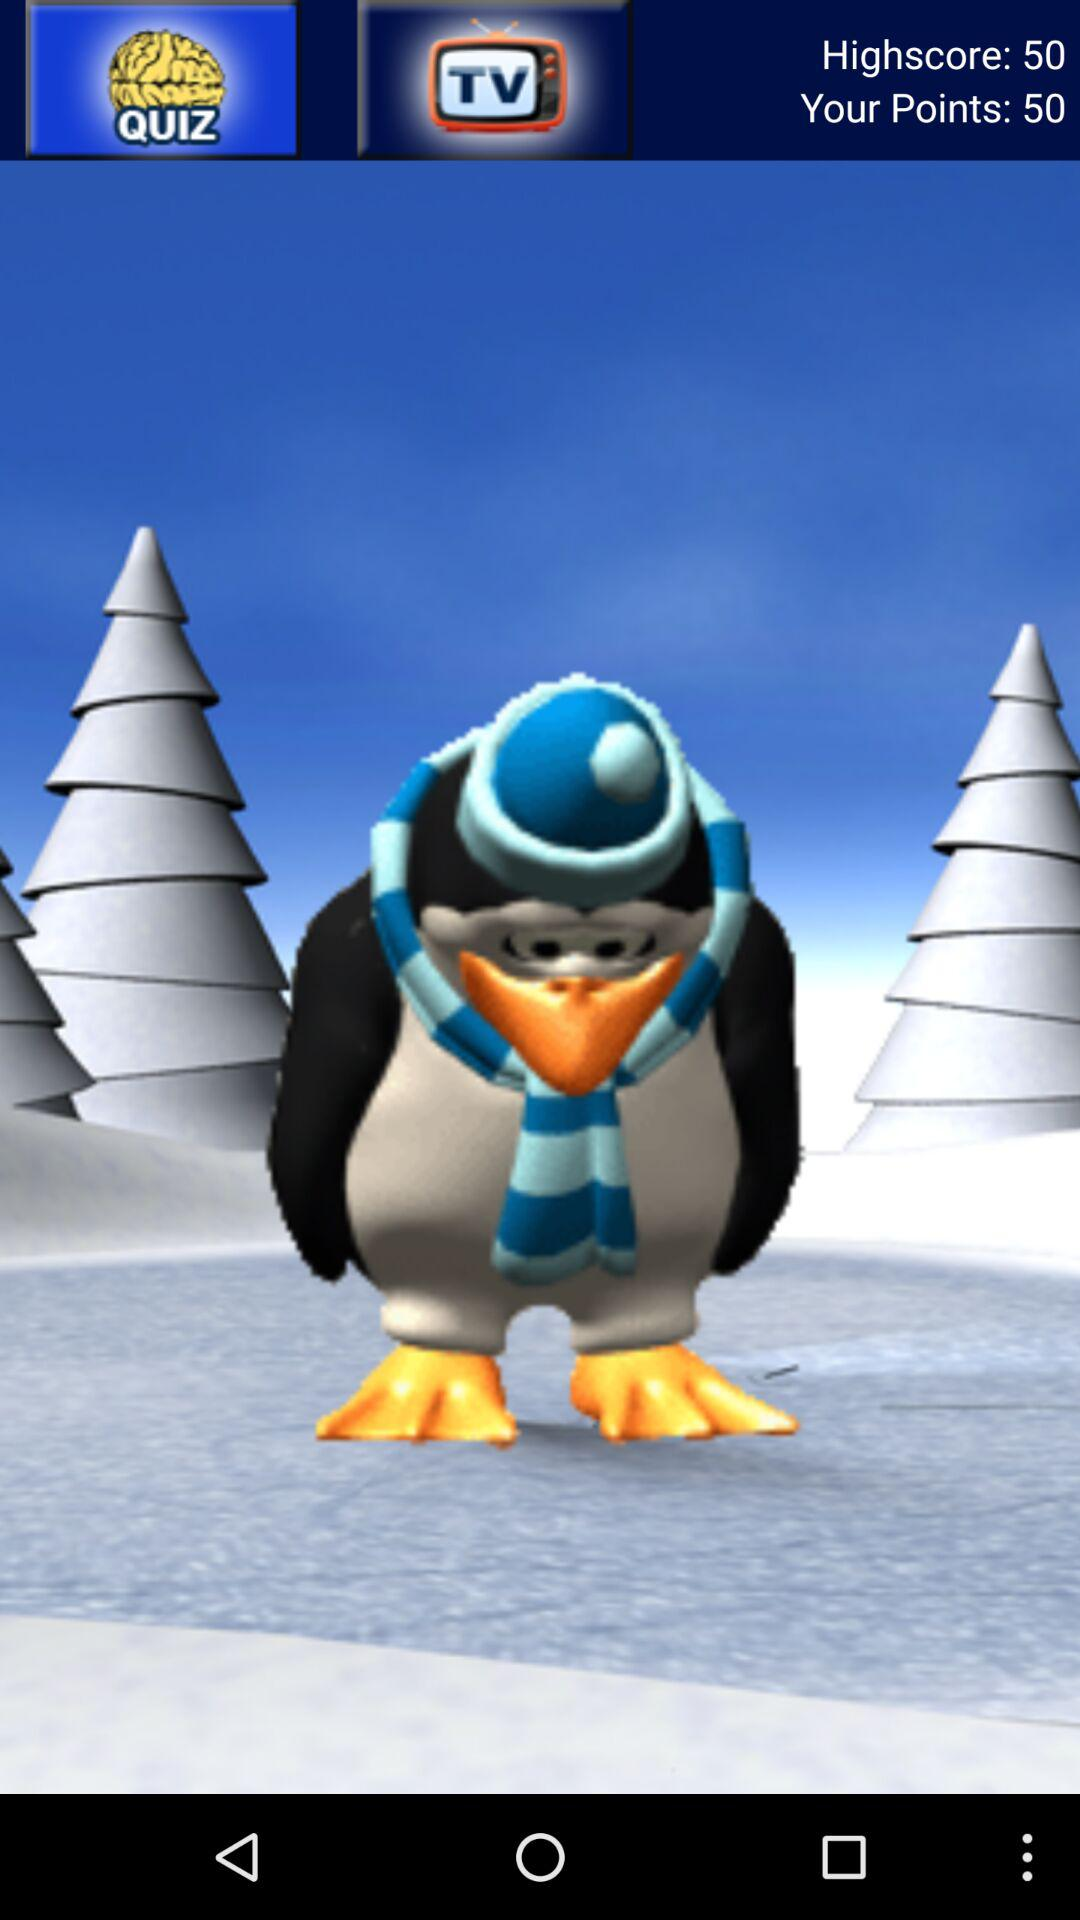What is the highscore? The highscore is 50. 